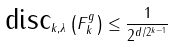<formula> <loc_0><loc_0><loc_500><loc_500>\text {disc} _ { k , \lambda } \left ( F ^ { g } _ { k } \right ) \leq \frac { 1 } { 2 ^ { d / 2 ^ { k - 1 } } }</formula> 